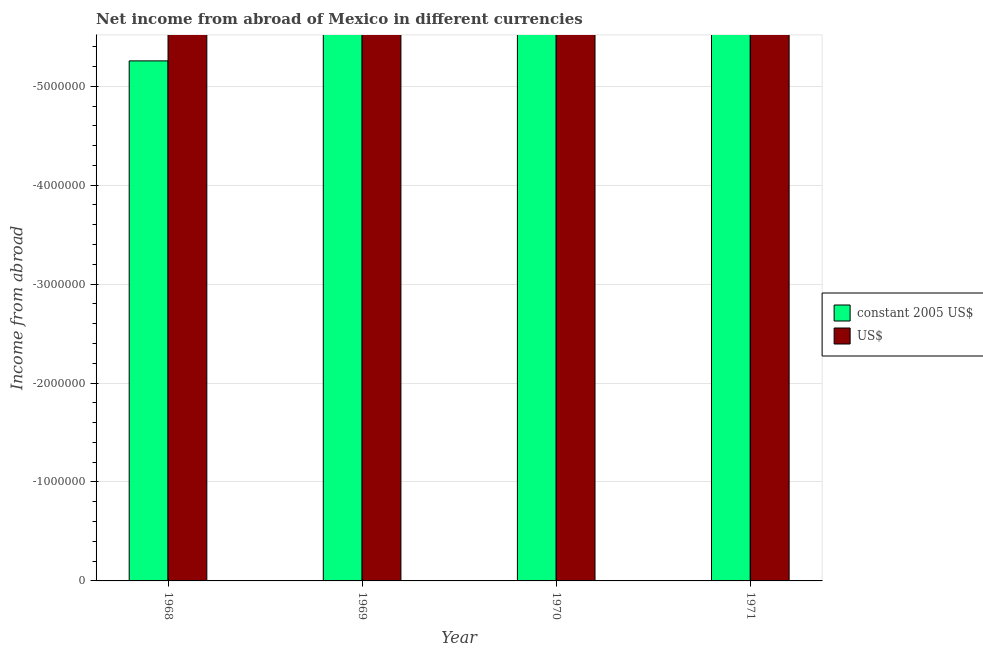How many different coloured bars are there?
Your answer should be very brief. 0. Are the number of bars on each tick of the X-axis equal?
Your response must be concise. Yes. How many bars are there on the 1st tick from the left?
Offer a terse response. 0. How many bars are there on the 2nd tick from the right?
Your answer should be very brief. 0. What is the label of the 2nd group of bars from the left?
Your response must be concise. 1969. In how many cases, is the number of bars for a given year not equal to the number of legend labels?
Your answer should be very brief. 4. What is the average income from abroad in constant 2005 us$ per year?
Your answer should be compact. 0. How many bars are there?
Your answer should be very brief. 0. Are all the bars in the graph horizontal?
Your answer should be very brief. No. How many years are there in the graph?
Offer a terse response. 4. Does the graph contain grids?
Keep it short and to the point. Yes. How many legend labels are there?
Give a very brief answer. 2. How are the legend labels stacked?
Provide a short and direct response. Vertical. What is the title of the graph?
Offer a terse response. Net income from abroad of Mexico in different currencies. Does "Number of departures" appear as one of the legend labels in the graph?
Provide a succinct answer. No. What is the label or title of the X-axis?
Make the answer very short. Year. What is the label or title of the Y-axis?
Give a very brief answer. Income from abroad. What is the Income from abroad in constant 2005 US$ in 1968?
Offer a very short reply. 0. What is the Income from abroad in US$ in 1968?
Provide a succinct answer. 0. What is the Income from abroad in constant 2005 US$ in 1969?
Make the answer very short. 0. What is the Income from abroad of US$ in 1969?
Your answer should be compact. 0. What is the Income from abroad of constant 2005 US$ in 1970?
Provide a succinct answer. 0. What is the Income from abroad of US$ in 1970?
Make the answer very short. 0. What is the Income from abroad of constant 2005 US$ in 1971?
Make the answer very short. 0. What is the Income from abroad of US$ in 1971?
Your response must be concise. 0. What is the total Income from abroad in constant 2005 US$ in the graph?
Offer a very short reply. 0. What is the average Income from abroad of constant 2005 US$ per year?
Your answer should be compact. 0. 